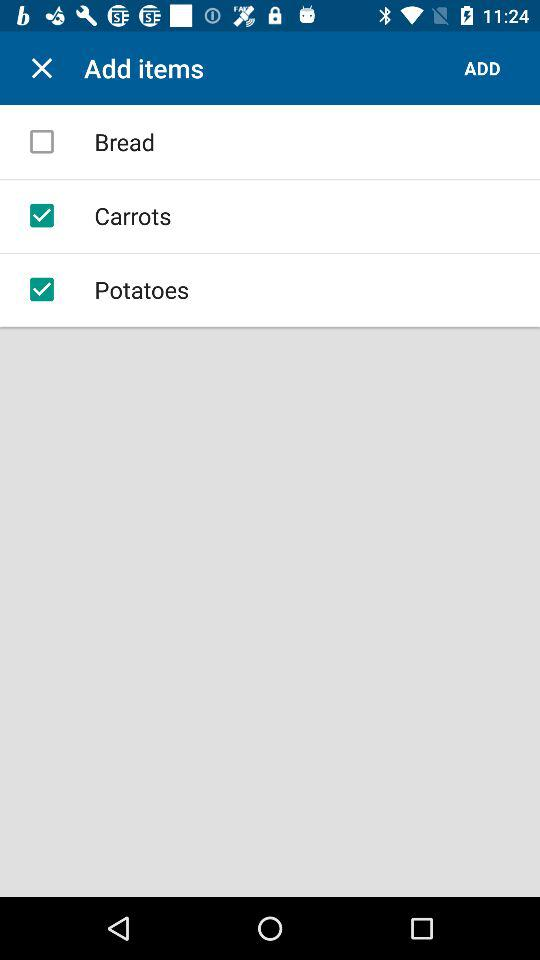What is the status of "Carrots"? The status of "Carrots" is "on". 